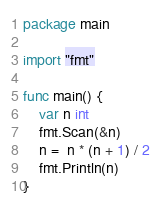<code> <loc_0><loc_0><loc_500><loc_500><_Go_>package main

import "fmt"

func main() {
	var n int
	fmt.Scan(&n)
	n =  n * (n + 1) / 2
	fmt.Println(n)
}
</code> 